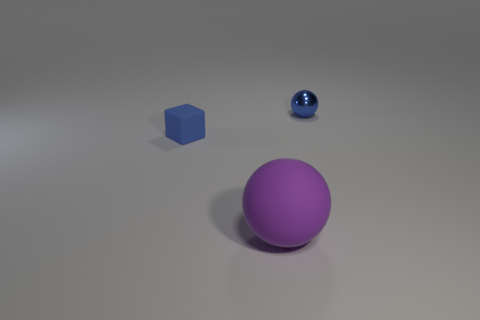Add 2 big things. How many objects exist? 5 Subtract all balls. How many objects are left? 1 Subtract 0 red blocks. How many objects are left? 3 Subtract all gray rubber objects. Subtract all small blue things. How many objects are left? 1 Add 3 big purple matte balls. How many big purple matte balls are left? 4 Add 1 large green matte blocks. How many large green matte blocks exist? 1 